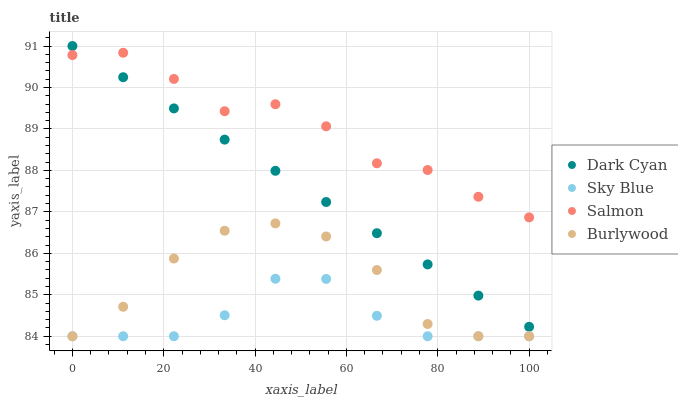Does Sky Blue have the minimum area under the curve?
Answer yes or no. Yes. Does Salmon have the maximum area under the curve?
Answer yes or no. Yes. Does Salmon have the minimum area under the curve?
Answer yes or no. No. Does Sky Blue have the maximum area under the curve?
Answer yes or no. No. Is Dark Cyan the smoothest?
Answer yes or no. Yes. Is Burlywood the roughest?
Answer yes or no. Yes. Is Sky Blue the smoothest?
Answer yes or no. No. Is Sky Blue the roughest?
Answer yes or no. No. Does Sky Blue have the lowest value?
Answer yes or no. Yes. Does Salmon have the lowest value?
Answer yes or no. No. Does Dark Cyan have the highest value?
Answer yes or no. Yes. Does Salmon have the highest value?
Answer yes or no. No. Is Sky Blue less than Dark Cyan?
Answer yes or no. Yes. Is Salmon greater than Sky Blue?
Answer yes or no. Yes. Does Burlywood intersect Sky Blue?
Answer yes or no. Yes. Is Burlywood less than Sky Blue?
Answer yes or no. No. Is Burlywood greater than Sky Blue?
Answer yes or no. No. Does Sky Blue intersect Dark Cyan?
Answer yes or no. No. 